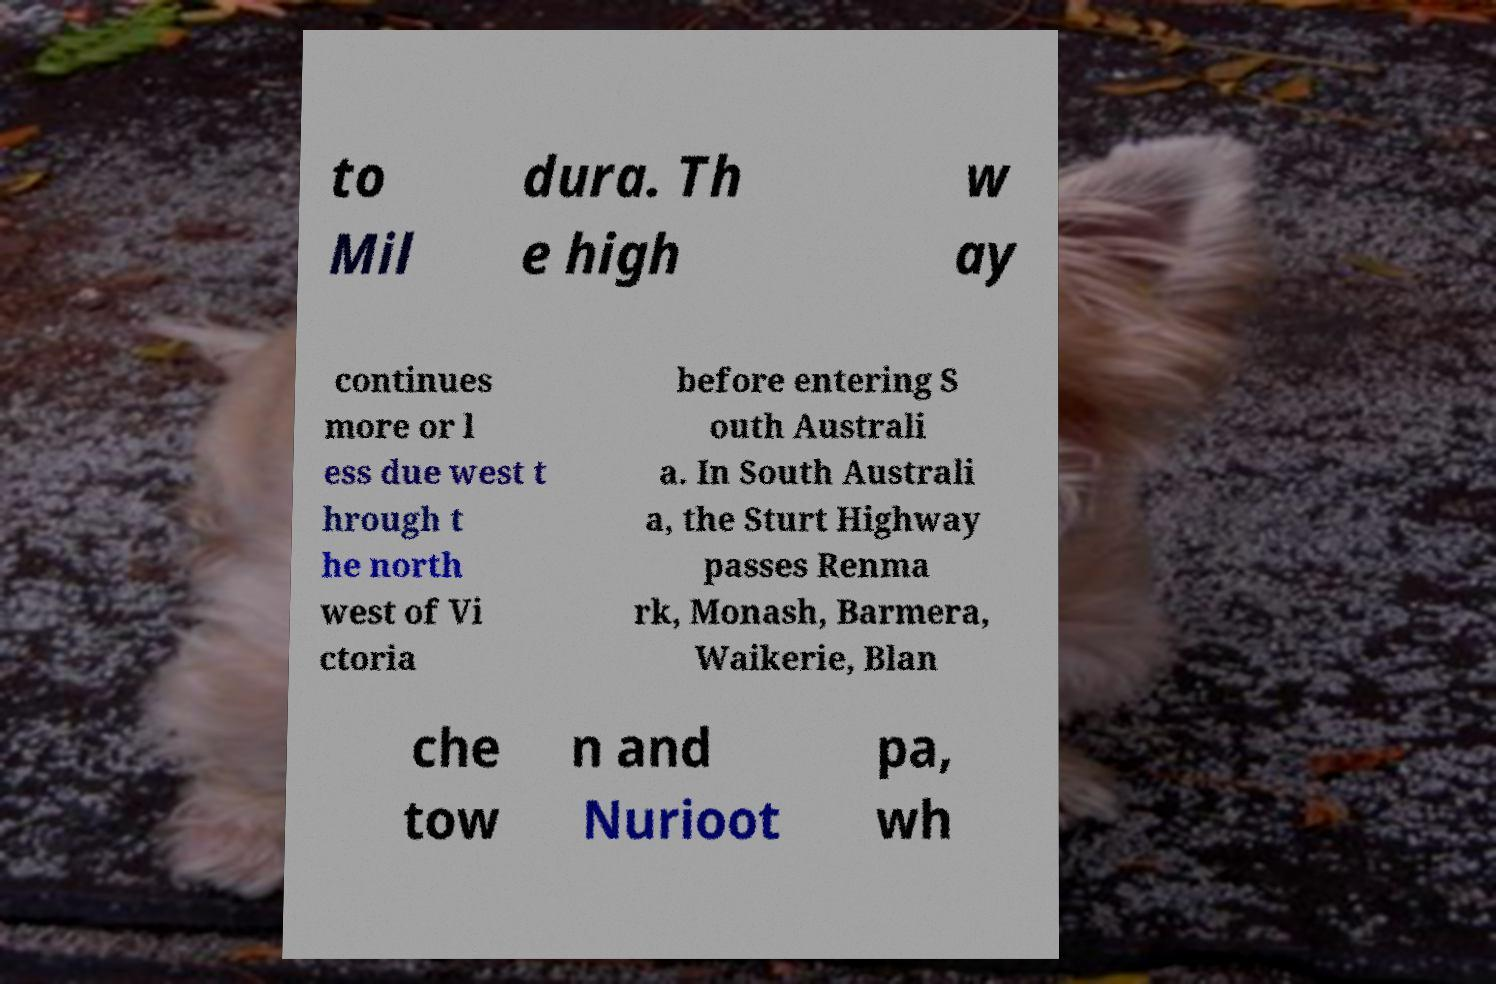What messages or text are displayed in this image? I need them in a readable, typed format. to Mil dura. Th e high w ay continues more or l ess due west t hrough t he north west of Vi ctoria before entering S outh Australi a. In South Australi a, the Sturt Highway passes Renma rk, Monash, Barmera, Waikerie, Blan che tow n and Nurioot pa, wh 